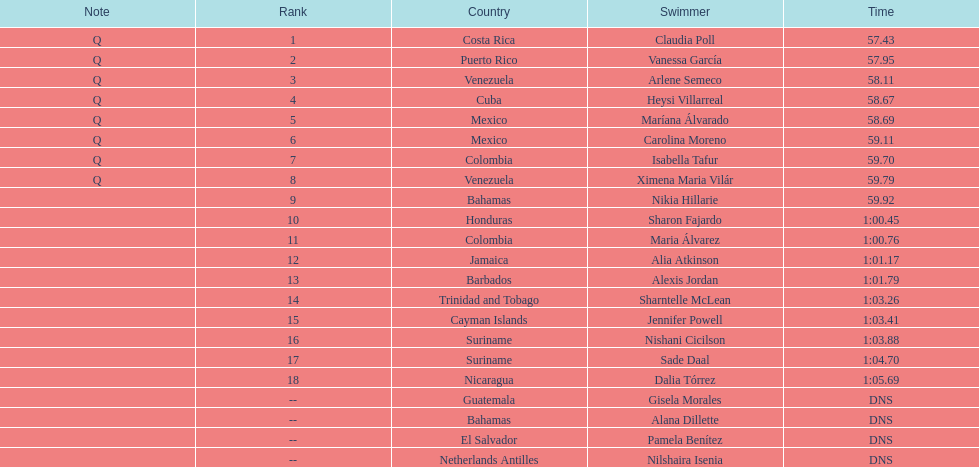How many swimmers did not swim? 4. 